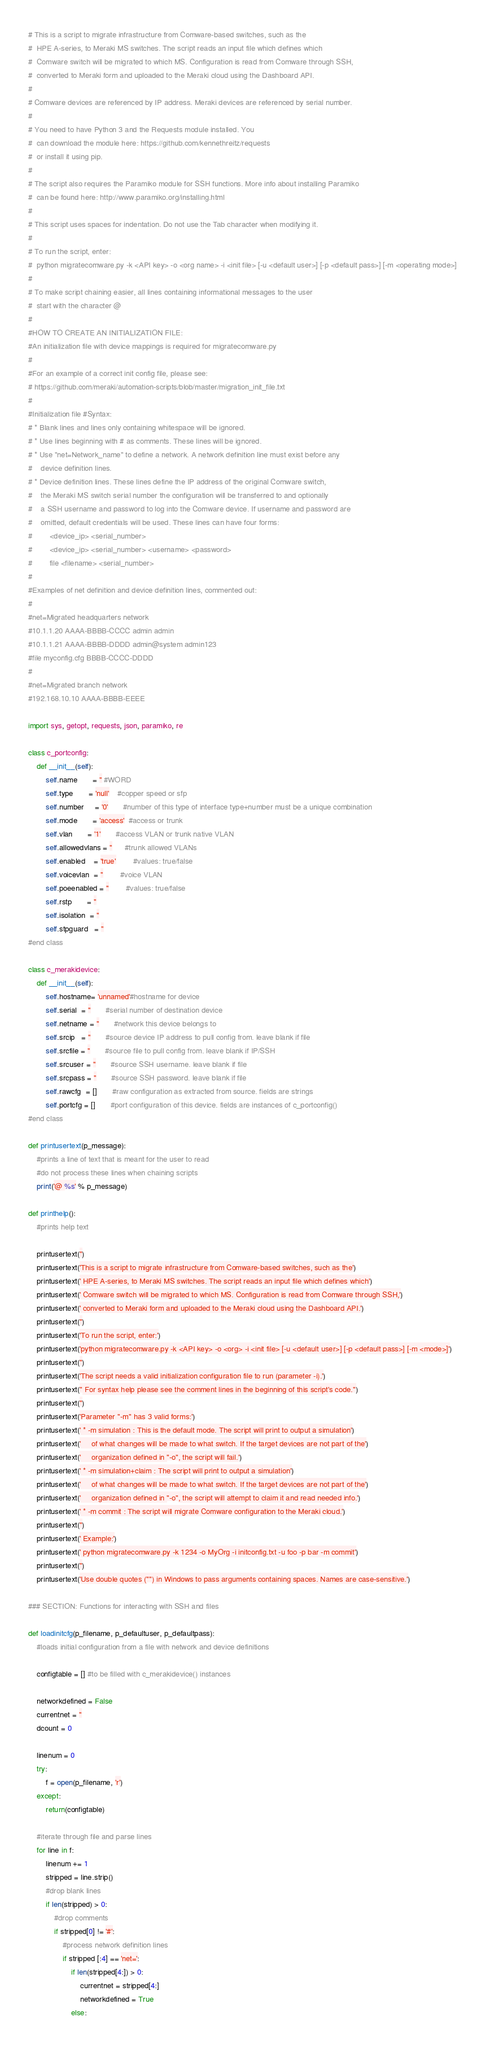<code> <loc_0><loc_0><loc_500><loc_500><_Python_># This is a script to migrate infrastructure from Comware-based switches, such as the
#  HPE A-series, to Meraki MS switches. The script reads an input file which defines which
#  Comware switch will be migrated to which MS. Configuration is read from Comware through SSH,
#  converted to Meraki form and uploaded to the Meraki cloud using the Dashboard API.
#
# Comware devices are referenced by IP address. Meraki devices are referenced by serial number.
#
# You need to have Python 3 and the Requests module installed. You
#  can download the module here: https://github.com/kennethreitz/requests
#  or install it using pip.
#
# The script also requires the Paramiko module for SSH functions. More info about installing Paramiko
#  can be found here: http://www.paramiko.org/installing.html
#
# This script uses spaces for indentation. Do not use the Tab character when modifying it.
#
# To run the script, enter:
#  python migratecomware.py -k <API key> -o <org name> -i <init file> [-u <default user>] [-p <default pass>] [-m <operating mode>]
#
# To make script chaining easier, all lines containing informational messages to the user
#  start with the character @
#
#HOW TO CREATE AN INITIALIZATION FILE:
#An initialization file with device mappings is required for migratecomware.py
#
#For an example of a correct init config file, please see:
# https://github.com/meraki/automation-scripts/blob/master/migration_init_file.txt
#
#Initialization file #Syntax:
# * Blank lines and lines only containing whitespace will be ignored.
# * Use lines beginning with # as comments. These lines will be ignored.
# * Use "net=Network_name" to define a network. A network definition line must exist before any
#    device definition lines.
# * Device definition lines. These lines define the IP address of the original Comware switch, 
#    the Meraki MS switch serial number the configuration will be transferred to and optionally
#    a SSH username and password to log into the Comware device. If username and password are
#    omitted, default credentials will be used. These lines can have four forms:
#        <device_ip> <serial_number>
#        <device_ip> <serial_number> <username> <password>
#        file <filename> <serial_number>
#
#Examples of net definition and device definition lines, commented out:
#
#net=Migrated headquarters network 
#10.1.1.20 AAAA-BBBB-CCCC admin admin
#10.1.1.21 AAAA-BBBB-DDDD admin@system admin123
#file myconfig.cfg BBBB-CCCC-DDDD
#
#net=Migrated branch network
#192.168.10.10 AAAA-BBBB-EEEE

import sys, getopt, requests, json, paramiko, re

class c_portconfig:
    def __init__(self):
        self.name       = '' #WORD
        self.type       = 'null'    #copper speed or sfp
        self.number     = '0'       #number of this type of interface type+number must be a unique combination
        self.mode       = 'access'  #access or trunk
        self.vlan       = '1'       #access VLAN or trunk native VLAN
        self.allowedvlans = ''      #trunk allowed VLANs
        self.enabled    = 'true'        #values: true/false
        self.voicevlan  = ''        #voice VLAN
        self.poeenabled = ''        #values: true/false
        self.rstp       = ''
        self.isolation  = ''
        self.stpguard   = ''
#end class   
   
class c_merakidevice:
    def __init__(self):
        self.hostname= 'unnamed'#hostname for device
        self.serial  = ''       #serial number of destination device
        self.netname = ''       #network this device belongs to
        self.srcip   = ''       #source device IP address to pull config from. leave blank if file
        self.srcfile = ''       #source file to pull config from. leave blank if IP/SSH
        self.srcuser = ''       #source SSH username. leave blank if file
        self.srcpass = ''       #source SSH password. leave blank if file
        self.rawcfg  = []       #raw configuration as extracted from source. fields are strings
        self.portcfg = []       #port configuration of this device. fields are instances of c_portconfig()
#end class        

def printusertext(p_message):
    #prints a line of text that is meant for the user to read
    #do not process these lines when chaining scripts
    print('@ %s' % p_message)

def printhelp():
    #prints help text

    printusertext('')
    printusertext('This is a script to migrate infrastructure from Comware-based switches, such as the')
    printusertext(' HPE A-series, to Meraki MS switches. The script reads an input file which defines which')
    printusertext(' Comware switch will be migrated to which MS. Configuration is read from Comware through SSH,')
    printusertext(' converted to Meraki form and uploaded to the Meraki cloud using the Dashboard API.')
    printusertext('')
    printusertext('To run the script, enter:')
    printusertext('python migratecomware.py -k <API key> -o <org> -i <init file> [-u <default user>] [-p <default pass>] [-m <mode>]')
    printusertext('')
    printusertext('The script needs a valid initialization configuration file to run (parameter -i).')
    printusertext(" For syntax help please see the comment lines in the beginning of this script's code.")
    printusertext('')
    printusertext('Parameter "-m" has 3 valid forms:')
    printusertext(' * -m simulation : This is the default mode. The script will print to output a simulation')
    printusertext('     of what changes will be made to what switch. If the target devices are not part of the')
    printusertext('     organization defined in "-o", the script will fail.')
    printusertext(' * -m simulation+claim : The script will print to output a simulation')
    printusertext('     of what changes will be made to what switch. If the target devices are not part of the')
    printusertext('     organization defined in "-o", the script will attempt to claim it and read needed info.')
    printusertext(' * -m commit : The script will migrate Comware configuration to the Meraki cloud.')
    printusertext('')
    printusertext(' Example:')
    printusertext(' python migratecomware.py -k 1234 -o MyOrg -i initconfig.txt -u foo -p bar -m commit')
    printusertext('')
    printusertext('Use double quotes ("") in Windows to pass arguments containing spaces. Names are case-sensitive.')

### SECTION: Functions for interacting with SSH and files    
    
def loadinitcfg(p_filename, p_defaultuser, p_defaultpass):
    #loads initial configuration from a file with network and device definitions
    
    configtable = [] #to be filled with c_merakidevice() instances
    
    networkdefined = False
    currentnet = ''
    dcount = 0
    
    linenum = 0
    try:
        f = open(p_filename, 'r')
    except:
        return(configtable)
    
    #iterate through file and parse lines
    for line in f:
        linenum += 1
        stripped = line.strip()
        #drop blank lines
        if len(stripped) > 0:
            #drop comments
            if stripped[0] != '#':
                #process network definition lines
                if stripped [:4] == 'net=':
                    if len(stripped[4:]) > 0:
                        currentnet = stripped[4:]
                        networkdefined = True
                    else:</code> 